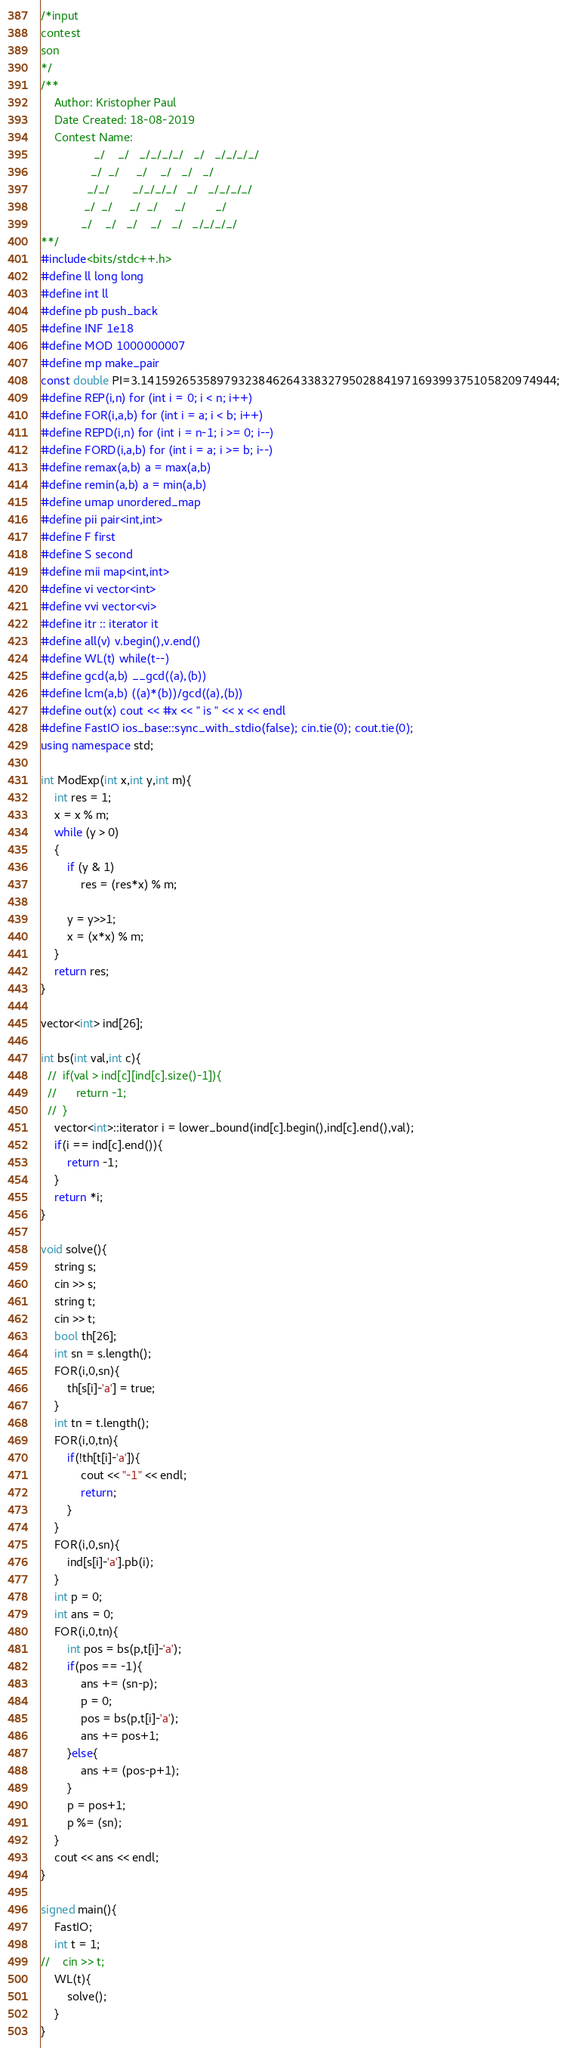Convert code to text. <code><loc_0><loc_0><loc_500><loc_500><_C++_>/*input
contest
son
*/
/**
    Author: Kristopher Paul
    Date Created: 18-08-2019
    Contest Name:
                _/    _/   _/_/_/_/   _/   _/_/_/_/
               _/  _/     _/    _/   _/   _/
              _/_/       _/_/_/_/   _/   _/_/_/_/
             _/  _/     _/  _/     _/         _/
            _/    _/   _/    _/   _/   _/_/_/_/
**/
#include<bits/stdc++.h>
#define ll long long
#define int ll
#define pb push_back
#define INF 1e18
#define MOD 1000000007
#define mp make_pair
const double PI=3.141592653589793238462643383279502884197169399375105820974944;
#define REP(i,n) for (int i = 0; i < n; i++)
#define FOR(i,a,b) for (int i = a; i < b; i++)
#define REPD(i,n) for (int i = n-1; i >= 0; i--)
#define FORD(i,a,b) for (int i = a; i >= b; i--)
#define remax(a,b) a = max(a,b)
#define remin(a,b) a = min(a,b)
#define umap unordered_map
#define pii pair<int,int>
#define F first
#define S second
#define mii map<int,int>
#define vi vector<int>
#define vvi vector<vi>
#define itr :: iterator it
#define all(v) v.begin(),v.end()
#define WL(t) while(t--)
#define gcd(a,b) __gcd((a),(b))
#define lcm(a,b) ((a)*(b))/gcd((a),(b))
#define out(x) cout << #x << " is " << x << endl
#define FastIO ios_base::sync_with_stdio(false); cin.tie(0); cout.tie(0);
using namespace std;

int ModExp(int x,int y,int m){
    int res = 1;
    x = x % m;
    while (y > 0)
    {
        if (y & 1)
            res = (res*x) % m;

        y = y>>1;
        x = (x*x) % m;
    }
    return res;
}

vector<int> ind[26];

int bs(int val,int c){
  //  if(val > ind[c][ind[c].size()-1]){
  //      return -1;
  //  }
    vector<int>::iterator i = lower_bound(ind[c].begin(),ind[c].end(),val);
    if(i == ind[c].end()){
        return -1;
    }
    return *i;
}

void solve(){
    string s;
    cin >> s;
    string t;
    cin >> t;
    bool th[26];
    int sn = s.length();
    FOR(i,0,sn){
        th[s[i]-'a'] = true;
    }
    int tn = t.length();
    FOR(i,0,tn){
        if(!th[t[i]-'a']){
            cout << "-1" << endl;
            return;
        }
    }
    FOR(i,0,sn){
        ind[s[i]-'a'].pb(i);
    }
    int p = 0;
    int ans = 0;
    FOR(i,0,tn){
        int pos = bs(p,t[i]-'a');
        if(pos == -1){
            ans += (sn-p);
            p = 0;
            pos = bs(p,t[i]-'a');
            ans += pos+1;
        }else{
            ans += (pos-p+1);
        }
        p = pos+1;
        p %= (sn);
    }
    cout << ans << endl;
}

signed main(){
    FastIO;
    int t = 1;
//    cin >> t;
    WL(t){
        solve();
    }
}
</code> 